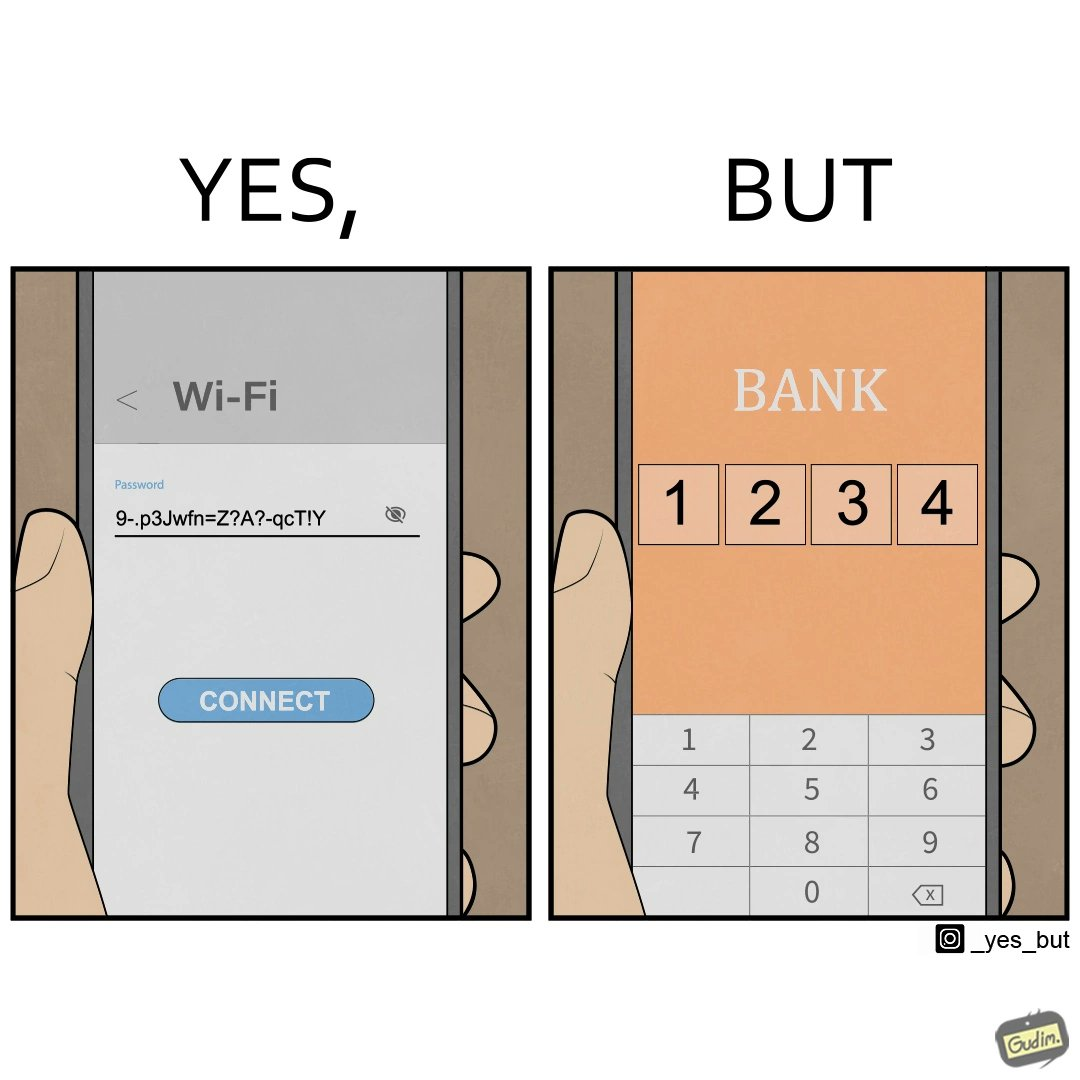Describe the satirical element in this image. The image is ironical, as a person sets a strong password for Wifi, while setting a very simple 4-digit PIN (1234 here) for online banking, where a much higher level of security would be required instead. 